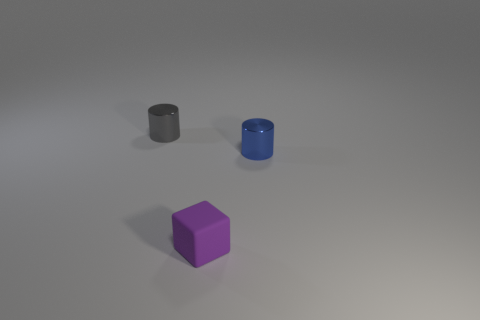Add 2 cyan rubber objects. How many objects exist? 5 Subtract all cubes. How many objects are left? 2 Add 2 matte objects. How many matte objects are left? 3 Add 2 gray cylinders. How many gray cylinders exist? 3 Subtract 0 brown blocks. How many objects are left? 3 Subtract all blue cylinders. Subtract all small rubber things. How many objects are left? 1 